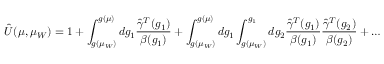<formula> <loc_0><loc_0><loc_500><loc_500>\hat { U } ( \mu , \mu _ { W } ) = 1 + \int _ { g ( \mu _ { W } ) } ^ { g ( \mu ) } d g _ { 1 } { \frac { \hat { \gamma } ^ { T } ( g _ { 1 } ) } { \beta ( g _ { 1 } ) } } + \int _ { g ( \mu _ { W } ) } ^ { g ( \mu ) } d g _ { 1 } \int _ { g ( \mu _ { W } ) } ^ { g _ { 1 } } d g _ { 2 } { \frac { \hat { \gamma } ^ { T } ( g _ { 1 } ) } { \beta ( g _ { 1 } ) } } { \frac { \hat { \gamma } ^ { T } ( g _ { 2 } ) } { \beta ( g _ { 2 } ) } } + \dots</formula> 